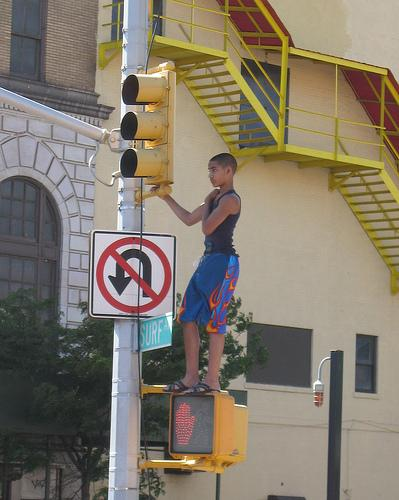In the context of the image, identify an object that indicates a restriction or prohibition. No u-turns street sign is an object that indicates restriction in the image. Mention a distinctive feature of the boy's clothing, as described in the captions. The boy is wearing blue shorts with flames on them. What is the boy standing on, according to the image captions? The boy is standing on a yellow colored digital do not walk sign. What is a noteworthy feature of the building in the image, as per the captions? A part of the building is made of brick, and it has a yellow fire escape on the side. Write a brief advertisement for a product related to a feature of the boy's attire. Introducing our fashionable blue shorts with eye-catching flame patterns! Stay cool and stylish this summer while showing off your unique sense of style! Based on the information provided, what do the captions suggest about the location of the image? The image seems to be set in a city street with a brick building, trees, and various street signs. Provide a suitable referential expression for the object with a red circle, based on the image captions. The round red sign with prohibition symbols, indicating restrictions and rules for drivers and pedestrians. What type of light is attached to the pole in the image? There is an orange light on a silver curved bar attached to the pole. Describe the colors and features of the no u-turn sign mentioned in the image. The no u-turn sign is white, red, and black in color. Describe the design of the street light mentioned in the captions. The street light is yellow and appears to be multi-directional with three lights on the sign. 